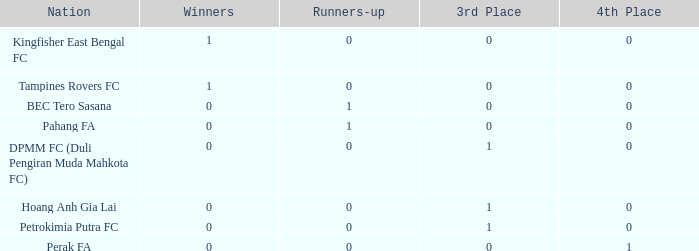Specify the supreme 3rd standing for the country associated with perak fa. 0.0. Can you give me this table as a dict? {'header': ['Nation', 'Winners', 'Runners-up', '3rd Place', '4th Place'], 'rows': [['Kingfisher East Bengal FC', '1', '0', '0', '0'], ['Tampines Rovers FC', '1', '0', '0', '0'], ['BEC Tero Sasana', '0', '1', '0', '0'], ['Pahang FA', '0', '1', '0', '0'], ['DPMM FC (Duli Pengiran Muda Mahkota FC)', '0', '0', '1', '0'], ['Hoang Anh Gia Lai', '0', '0', '1', '0'], ['Petrokimia Putra FC', '0', '0', '1', '0'], ['Perak FA', '0', '0', '0', '1']]} 